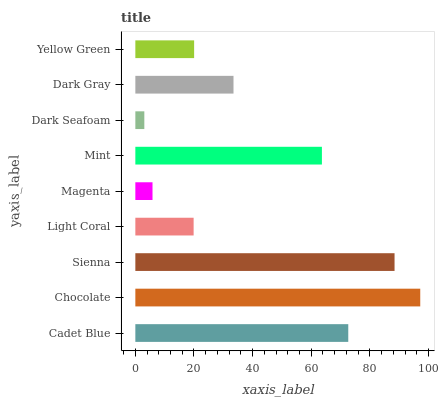Is Dark Seafoam the minimum?
Answer yes or no. Yes. Is Chocolate the maximum?
Answer yes or no. Yes. Is Sienna the minimum?
Answer yes or no. No. Is Sienna the maximum?
Answer yes or no. No. Is Chocolate greater than Sienna?
Answer yes or no. Yes. Is Sienna less than Chocolate?
Answer yes or no. Yes. Is Sienna greater than Chocolate?
Answer yes or no. No. Is Chocolate less than Sienna?
Answer yes or no. No. Is Dark Gray the high median?
Answer yes or no. Yes. Is Dark Gray the low median?
Answer yes or no. Yes. Is Chocolate the high median?
Answer yes or no. No. Is Mint the low median?
Answer yes or no. No. 